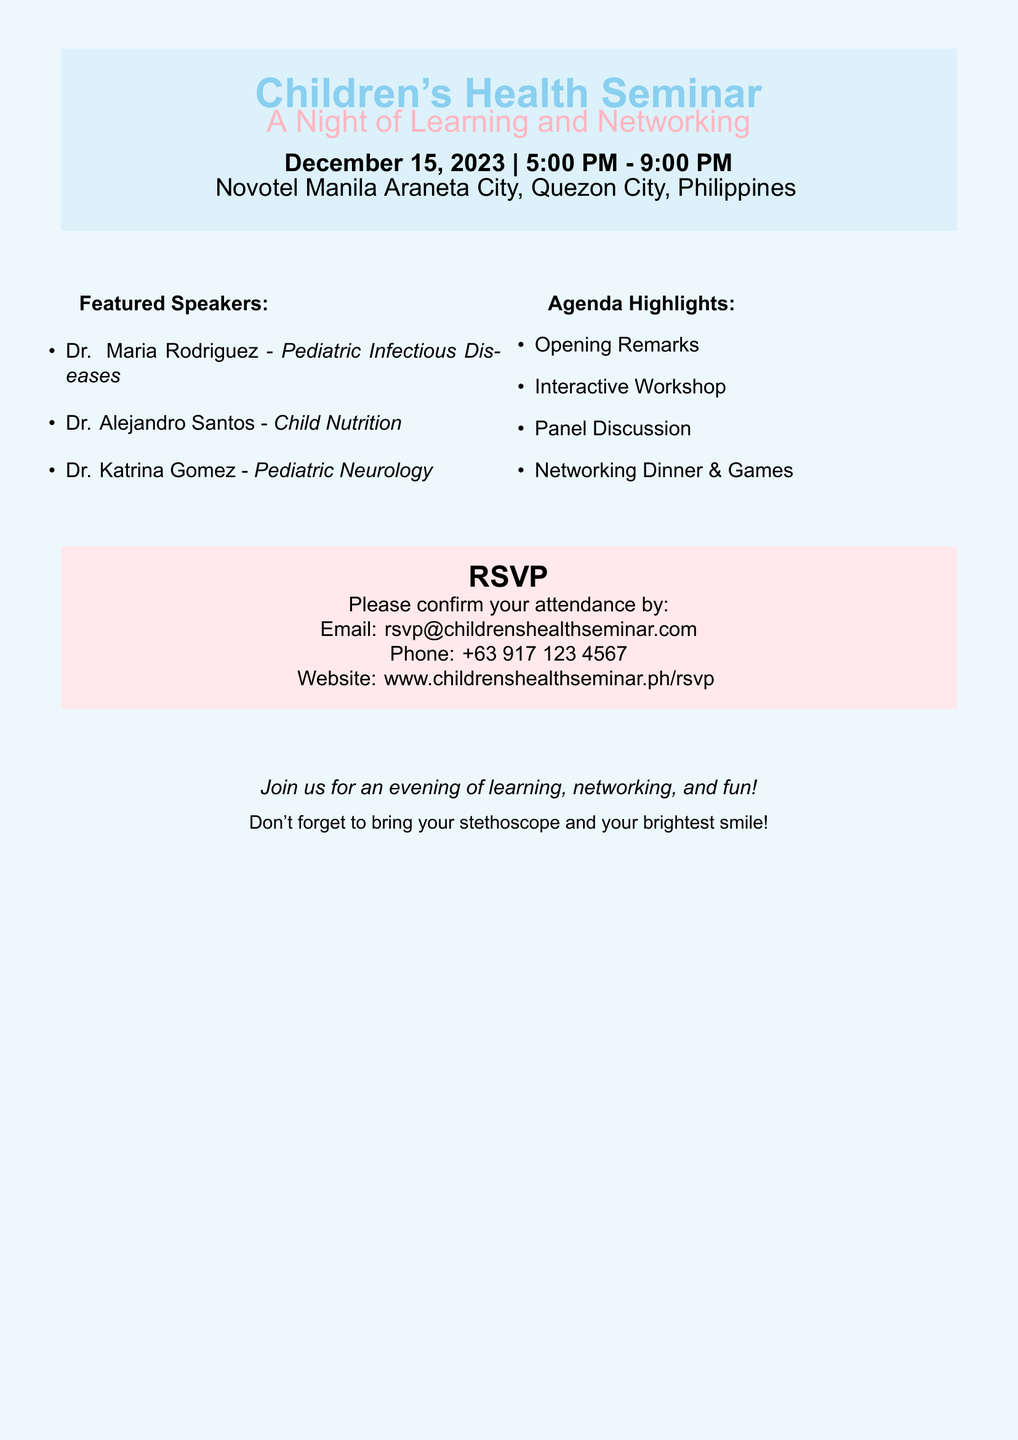What is the date of the seminar? The date of the seminar is provided in the document as December 15, 2023.
Answer: December 15, 2023 What time does the seminar start? The start time for the seminar is mentioned in the document.
Answer: 5:00 PM Who is one of the featured speakers? The document lists specific speakers and their specialties; one of them is Dr. Maria Rodriguez.
Answer: Dr. Maria Rodriguez What is one agenda highlight of the seminar? The document lists several agenda highlights; one of them is "Interactive Workshop."
Answer: Interactive Workshop What is the venue for the event? The venue is mentioned in the document clearly as Novotel Manila Araneta City.
Answer: Novotel Manila Araneta City How can attendees confirm their attendance? The document provides multiple options for confirming attendance; one method is via email.
Answer: Email What is required to bring to the seminar? The final lines in the document suggest attendees bring a specific item; one mentioned is a stethoscope.
Answer: Stethoscope What is the theme of the event? The theme is indicated by the title and subtitle of the seminar.
Answer: A Night of Learning and Networking What type of dinner is included in the agenda? The agenda mentions a specific style of dinner, which is highlighted as a social event.
Answer: Networking Dinner & Games 